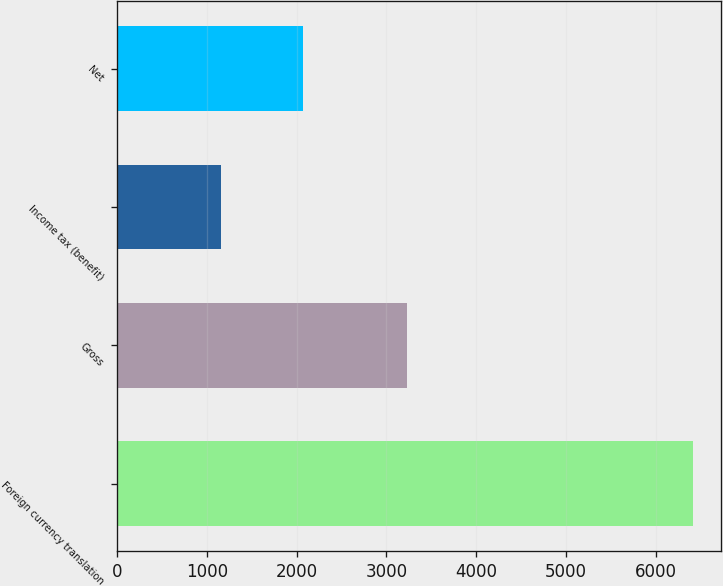Convert chart. <chart><loc_0><loc_0><loc_500><loc_500><bar_chart><fcel>Foreign currency translation<fcel>Gross<fcel>Income tax (benefit)<fcel>Net<nl><fcel>6407<fcel>3230<fcel>1157<fcel>2073<nl></chart> 